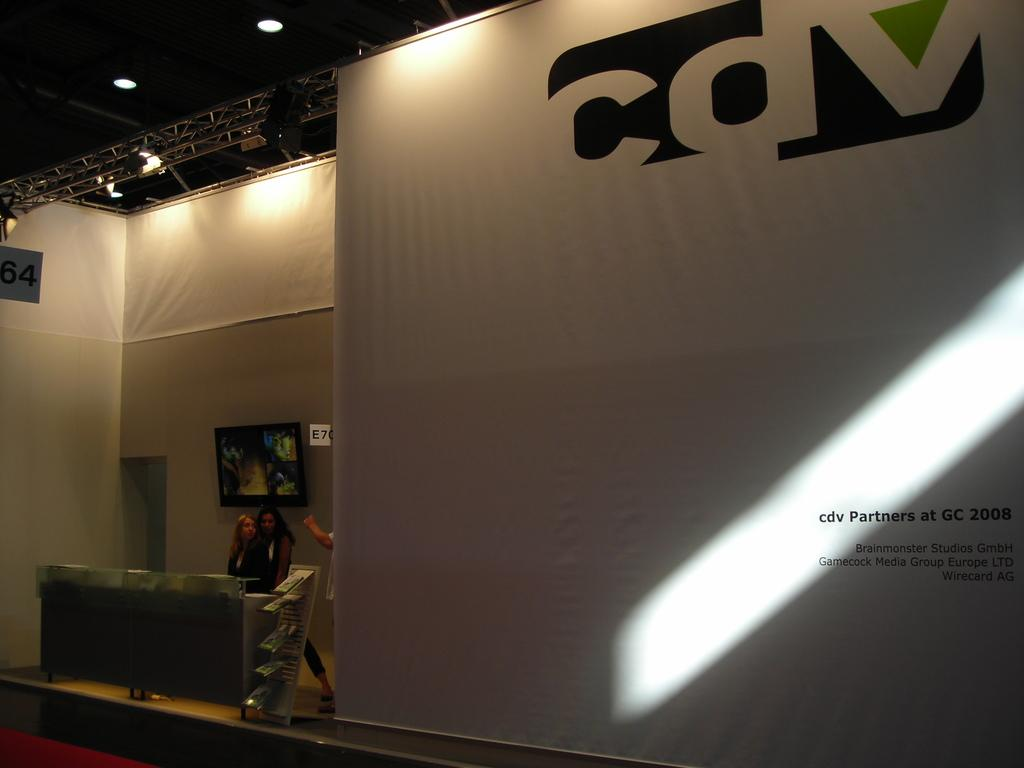<image>
Create a compact narrative representing the image presented. Two women are standing next to a large stage with a wall that says cdv Partners at GC 2008. 